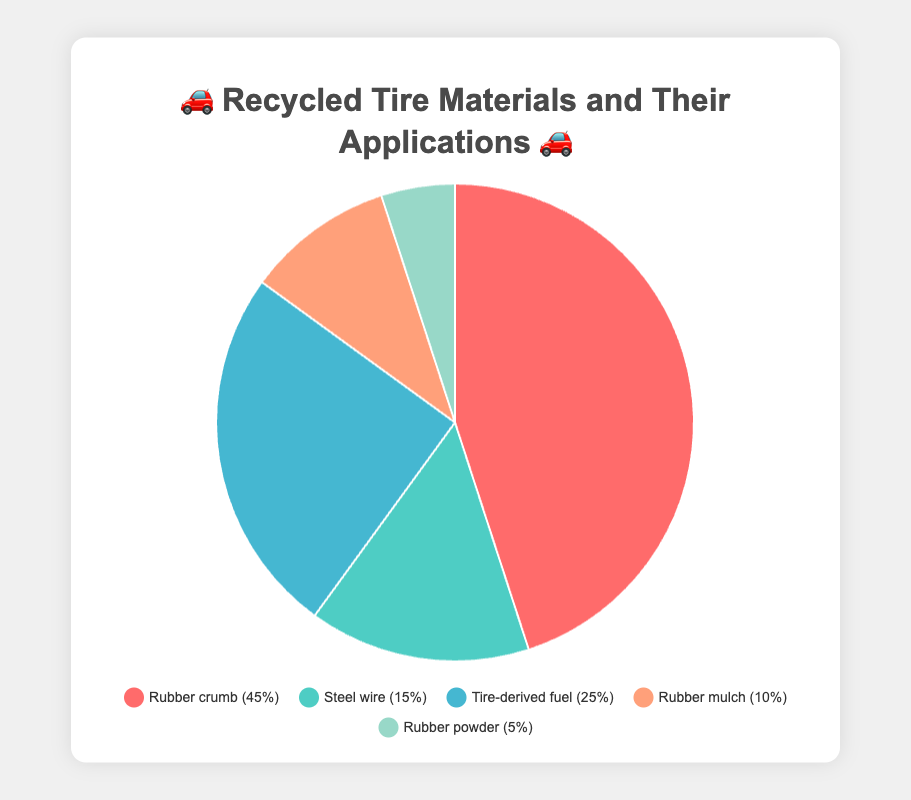What is the most common recycled tire material and its main applications? The pie chart shows that Rubber crumb has the highest percentage (45%). The main applications for Rubber crumb are Sports fields 🏟️ and Playground surfaces 🛝.
Answer: Rubber crumb (Sports fields 🏟️, Playground surfaces 🛝) What percentage of recycled tire materials is used for tire-derived fuel and what are its applications? According to the pie chart, Tire-derived fuel makes up 25% of the recycled tire materials. Its applications are Cement kilns 🏭 and Paper mills 📄.
Answer: 25% (Cement kilns 🏭, Paper mills 📄) How much more prevalent is Rubber crumb compared to Rubber powder? The pie chart indicates that Rubber crumb constitutes 45% while Rubber powder constitutes 5%. The difference in their prevalence is 45% - 5% = 40%.
Answer: 40% What materials are used for both sports fields and playground surfaces? By looking at the pie chart, we see that Rubber crumb is used for Sports fields 🏟️ and Playground surfaces 🛝.
Answer: Rubber crumb Which recycled tire materials occupy the smallest and largest portions of the chart? The pie chart shows that Rubber powder has the smallest portion at 5% and Rubber crumb has the largest portion at 45%.
Answer: Rubber powder (smallest), Rubber crumb (largest) What is the combined percentage of materials used in construction and landscaping? Steel wire (15%), used in Construction reinforcement, and Rubber mulch (10%), used in Landscaping, have a combined percentage of 15% + 10% = 25%.
Answer: 25% What are the possible applications for steel wire derived from recycled tires? According to the pie chart, Steel wire from recycled tires can be used for Construction reinforcement 🏗️ and Scrap metal recycling ♻️.
Answer: Construction reinforcement 🏗️, Scrap metal recycling ♻️ Which material has a higher percentage: Rubber mulch or Tire-derived fuel? The pie chart shows that Tire-derived fuel has a higher percentage (25%) compared to Rubber mulch which has 10%.
Answer: Tire-derived fuel Which two materials together make up exactly 20% of the recycled tire materials? The pie chart indicates that Rubber powder and Rubber mulch are the two materials, with percentages of 5% and 10% respectively, which together sum to exactly 15%.
Answer: None What materials are used for road asphalt and what percentage do they represent? The pie chart provides that Rubber powder, which is used in Road asphalt 🛣️, represents 5% of the recycled tire materials.
Answer: Rubber powder, 5% 